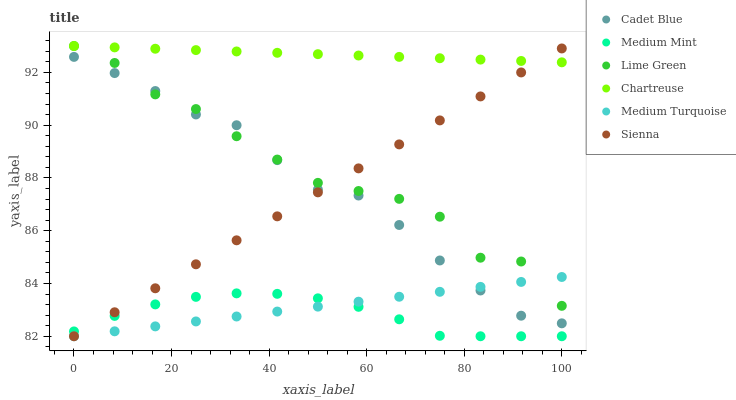Does Medium Mint have the minimum area under the curve?
Answer yes or no. Yes. Does Chartreuse have the maximum area under the curve?
Answer yes or no. Yes. Does Cadet Blue have the minimum area under the curve?
Answer yes or no. No. Does Cadet Blue have the maximum area under the curve?
Answer yes or no. No. Is Medium Turquoise the smoothest?
Answer yes or no. Yes. Is Lime Green the roughest?
Answer yes or no. Yes. Is Cadet Blue the smoothest?
Answer yes or no. No. Is Cadet Blue the roughest?
Answer yes or no. No. Does Medium Mint have the lowest value?
Answer yes or no. Yes. Does Cadet Blue have the lowest value?
Answer yes or no. No. Does Lime Green have the highest value?
Answer yes or no. Yes. Does Cadet Blue have the highest value?
Answer yes or no. No. Is Cadet Blue less than Chartreuse?
Answer yes or no. Yes. Is Chartreuse greater than Medium Mint?
Answer yes or no. Yes. Does Sienna intersect Cadet Blue?
Answer yes or no. Yes. Is Sienna less than Cadet Blue?
Answer yes or no. No. Is Sienna greater than Cadet Blue?
Answer yes or no. No. Does Cadet Blue intersect Chartreuse?
Answer yes or no. No. 